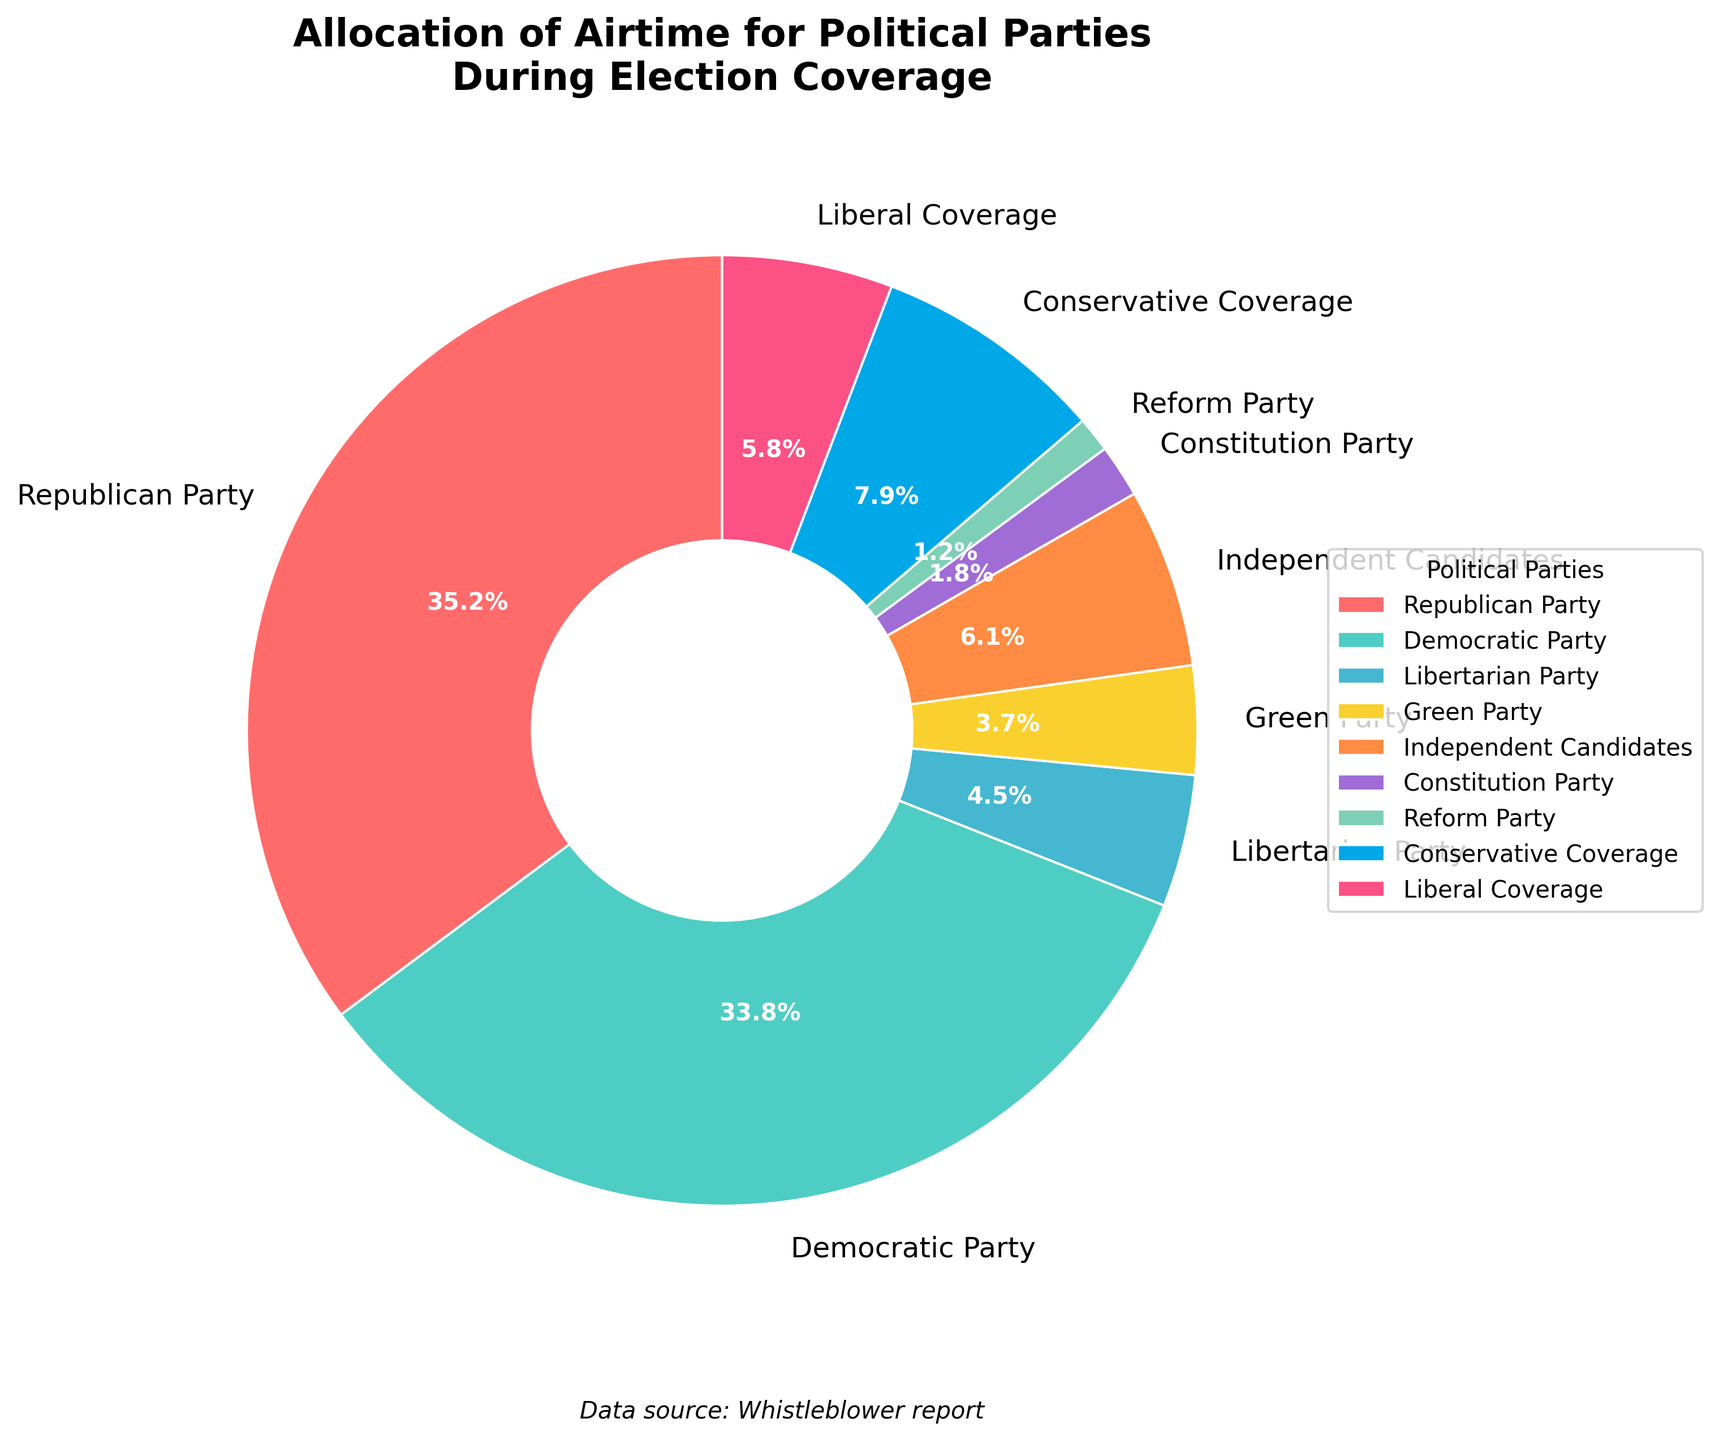Which political party received the most airtime during election coverage? By looking at the pie chart, the segment with the largest size should be identified. The Republican Party has the largest segment, therefore, they received the most airtime.
Answer: Republican Party Which two parties together received over 60% of the airtime? To find this, identify the two largest segments in the pie chart. Then, sum their percentages. The Republican Party (35.2%) and the Democratic Party (33.8%) together received 35.2 + 33.8 = 69%, which is over 60%.
Answer: Republican Party and Democratic Party How does the airtime allocated to the Libertarian Party compare to that allocated to the Green Party? Both parties have relatively small segments, but the Libertarian Party's segment is slightly larger than the Green Party's. The corresponding percentages are 4.5% for Libertarian and 3.7% for Green Party.
Answer: Libertarian Party received more airtime than Green Party What is the combined airtime percentage for Independent Candidates and Constitution Party? Sum up the airtime percentages of Independent Candidates (6.1%) and Constitution Party (1.8%). The combined airtime is 6.1 + 1.8 = 7.9%.
Answer: 7.9% Which type of coverage received more airtime: Conservative Coverage or Liberal Coverage? Compare the sizes of the segments labeled "Conservative Coverage" and "Liberal Coverage". Conservative Coverage has 7.9%, while Liberal Coverage has 5.8%. Therefore, Conservative Coverage received more airtime.
Answer: Conservative Coverage What is the difference in airtime percentage between the Democratic Party and the Republican Party? Subtract the smaller percentage from the larger one. Republican Party has 35.2% and Democratic Party has 33.8%. The difference is 35.2 - 33.8 = 1.4%.
Answer: 1.4% What percentage of the airtime was allocated to parties outside the Republican and Democratic parties? Sum up the airtime percentages of all other parties and types of coverage. These are Libertarian Party (4.5%), Green Party (3.7%), Independent Candidates (6.1%), Constitution Party (1.8%), Reform Party (1.2%), Conservative Coverage (7.9%), and Liberal Coverage (5.8%). Combined, these total 4.5 + 3.7 + 6.1 + 1.8 + 1.2 + 7.9 + 5.8 = 31.0%.
Answer: 31.0% 